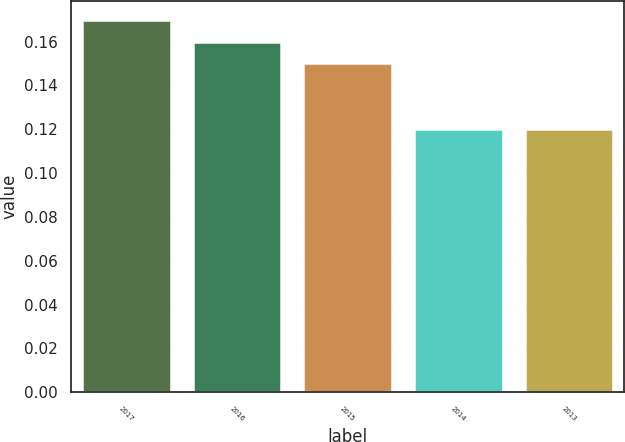Convert chart. <chart><loc_0><loc_0><loc_500><loc_500><bar_chart><fcel>2017<fcel>2016<fcel>2015<fcel>2014<fcel>2013<nl><fcel>0.17<fcel>0.16<fcel>0.15<fcel>0.12<fcel>0.12<nl></chart> 